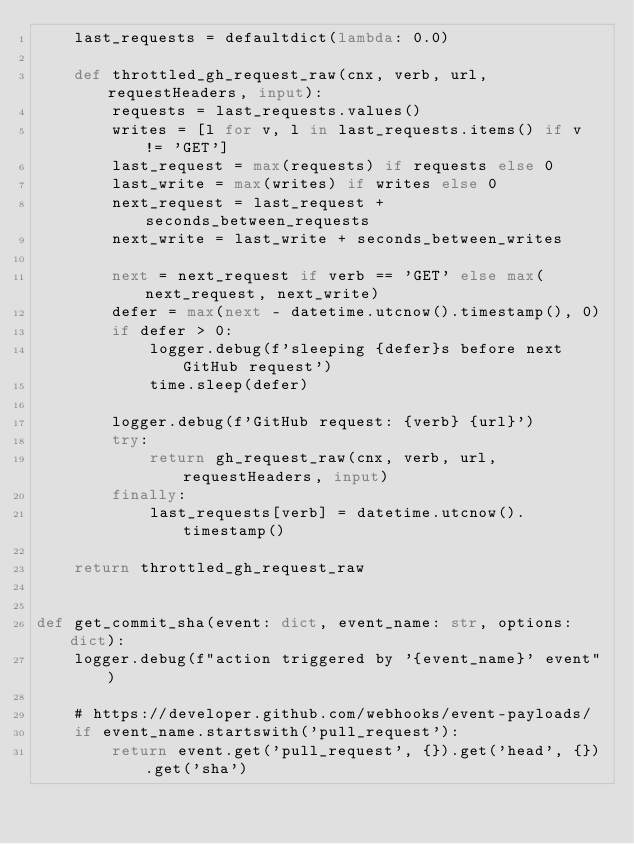<code> <loc_0><loc_0><loc_500><loc_500><_Python_>    last_requests = defaultdict(lambda: 0.0)

    def throttled_gh_request_raw(cnx, verb, url, requestHeaders, input):
        requests = last_requests.values()
        writes = [l for v, l in last_requests.items() if v != 'GET']
        last_request = max(requests) if requests else 0
        last_write = max(writes) if writes else 0
        next_request = last_request + seconds_between_requests
        next_write = last_write + seconds_between_writes

        next = next_request if verb == 'GET' else max(next_request, next_write)
        defer = max(next - datetime.utcnow().timestamp(), 0)
        if defer > 0:
            logger.debug(f'sleeping {defer}s before next GitHub request')
            time.sleep(defer)

        logger.debug(f'GitHub request: {verb} {url}')
        try:
            return gh_request_raw(cnx, verb, url, requestHeaders, input)
        finally:
            last_requests[verb] = datetime.utcnow().timestamp()

    return throttled_gh_request_raw


def get_commit_sha(event: dict, event_name: str, options: dict):
    logger.debug(f"action triggered by '{event_name}' event")

    # https://developer.github.com/webhooks/event-payloads/
    if event_name.startswith('pull_request'):
        return event.get('pull_request', {}).get('head', {}).get('sha')
</code> 